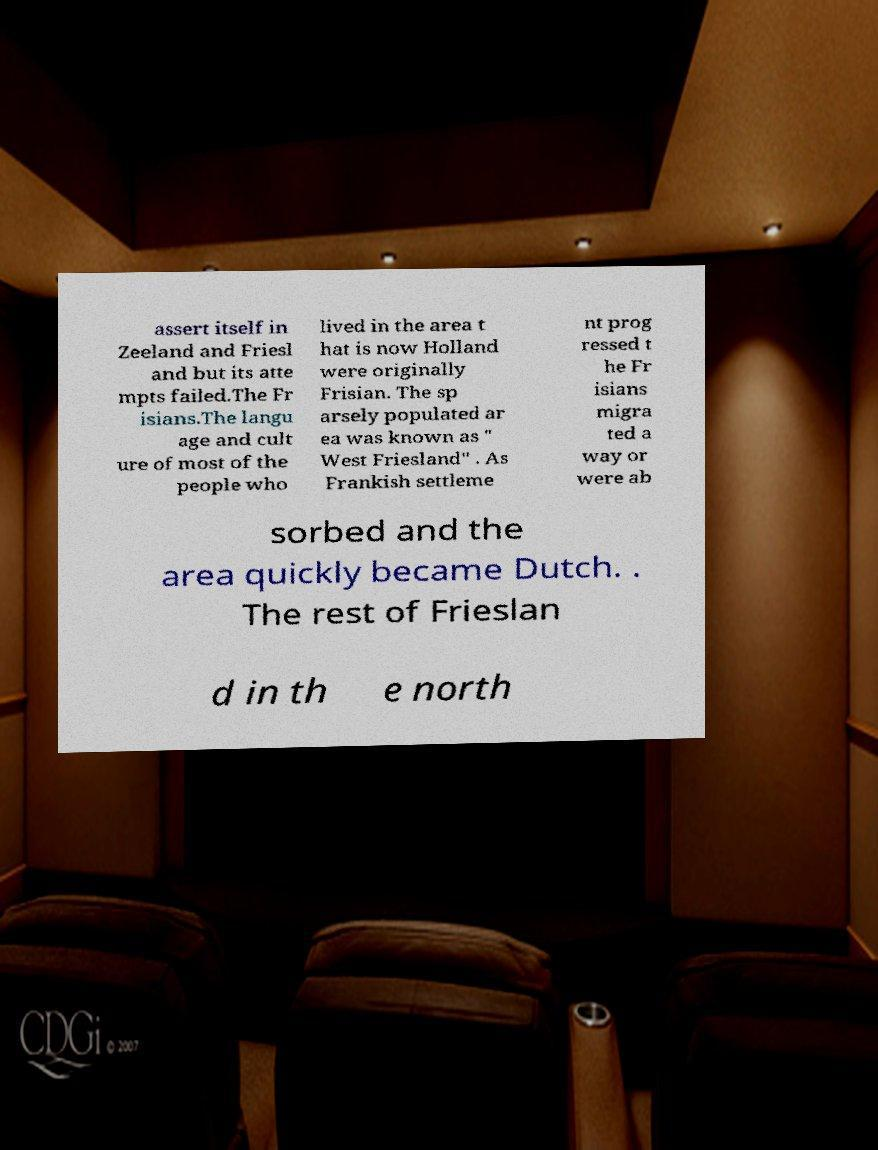For documentation purposes, I need the text within this image transcribed. Could you provide that? assert itself in Zeeland and Friesl and but its atte mpts failed.The Fr isians.The langu age and cult ure of most of the people who lived in the area t hat is now Holland were originally Frisian. The sp arsely populated ar ea was known as " West Friesland" . As Frankish settleme nt prog ressed t he Fr isians migra ted a way or were ab sorbed and the area quickly became Dutch. . The rest of Frieslan d in th e north 